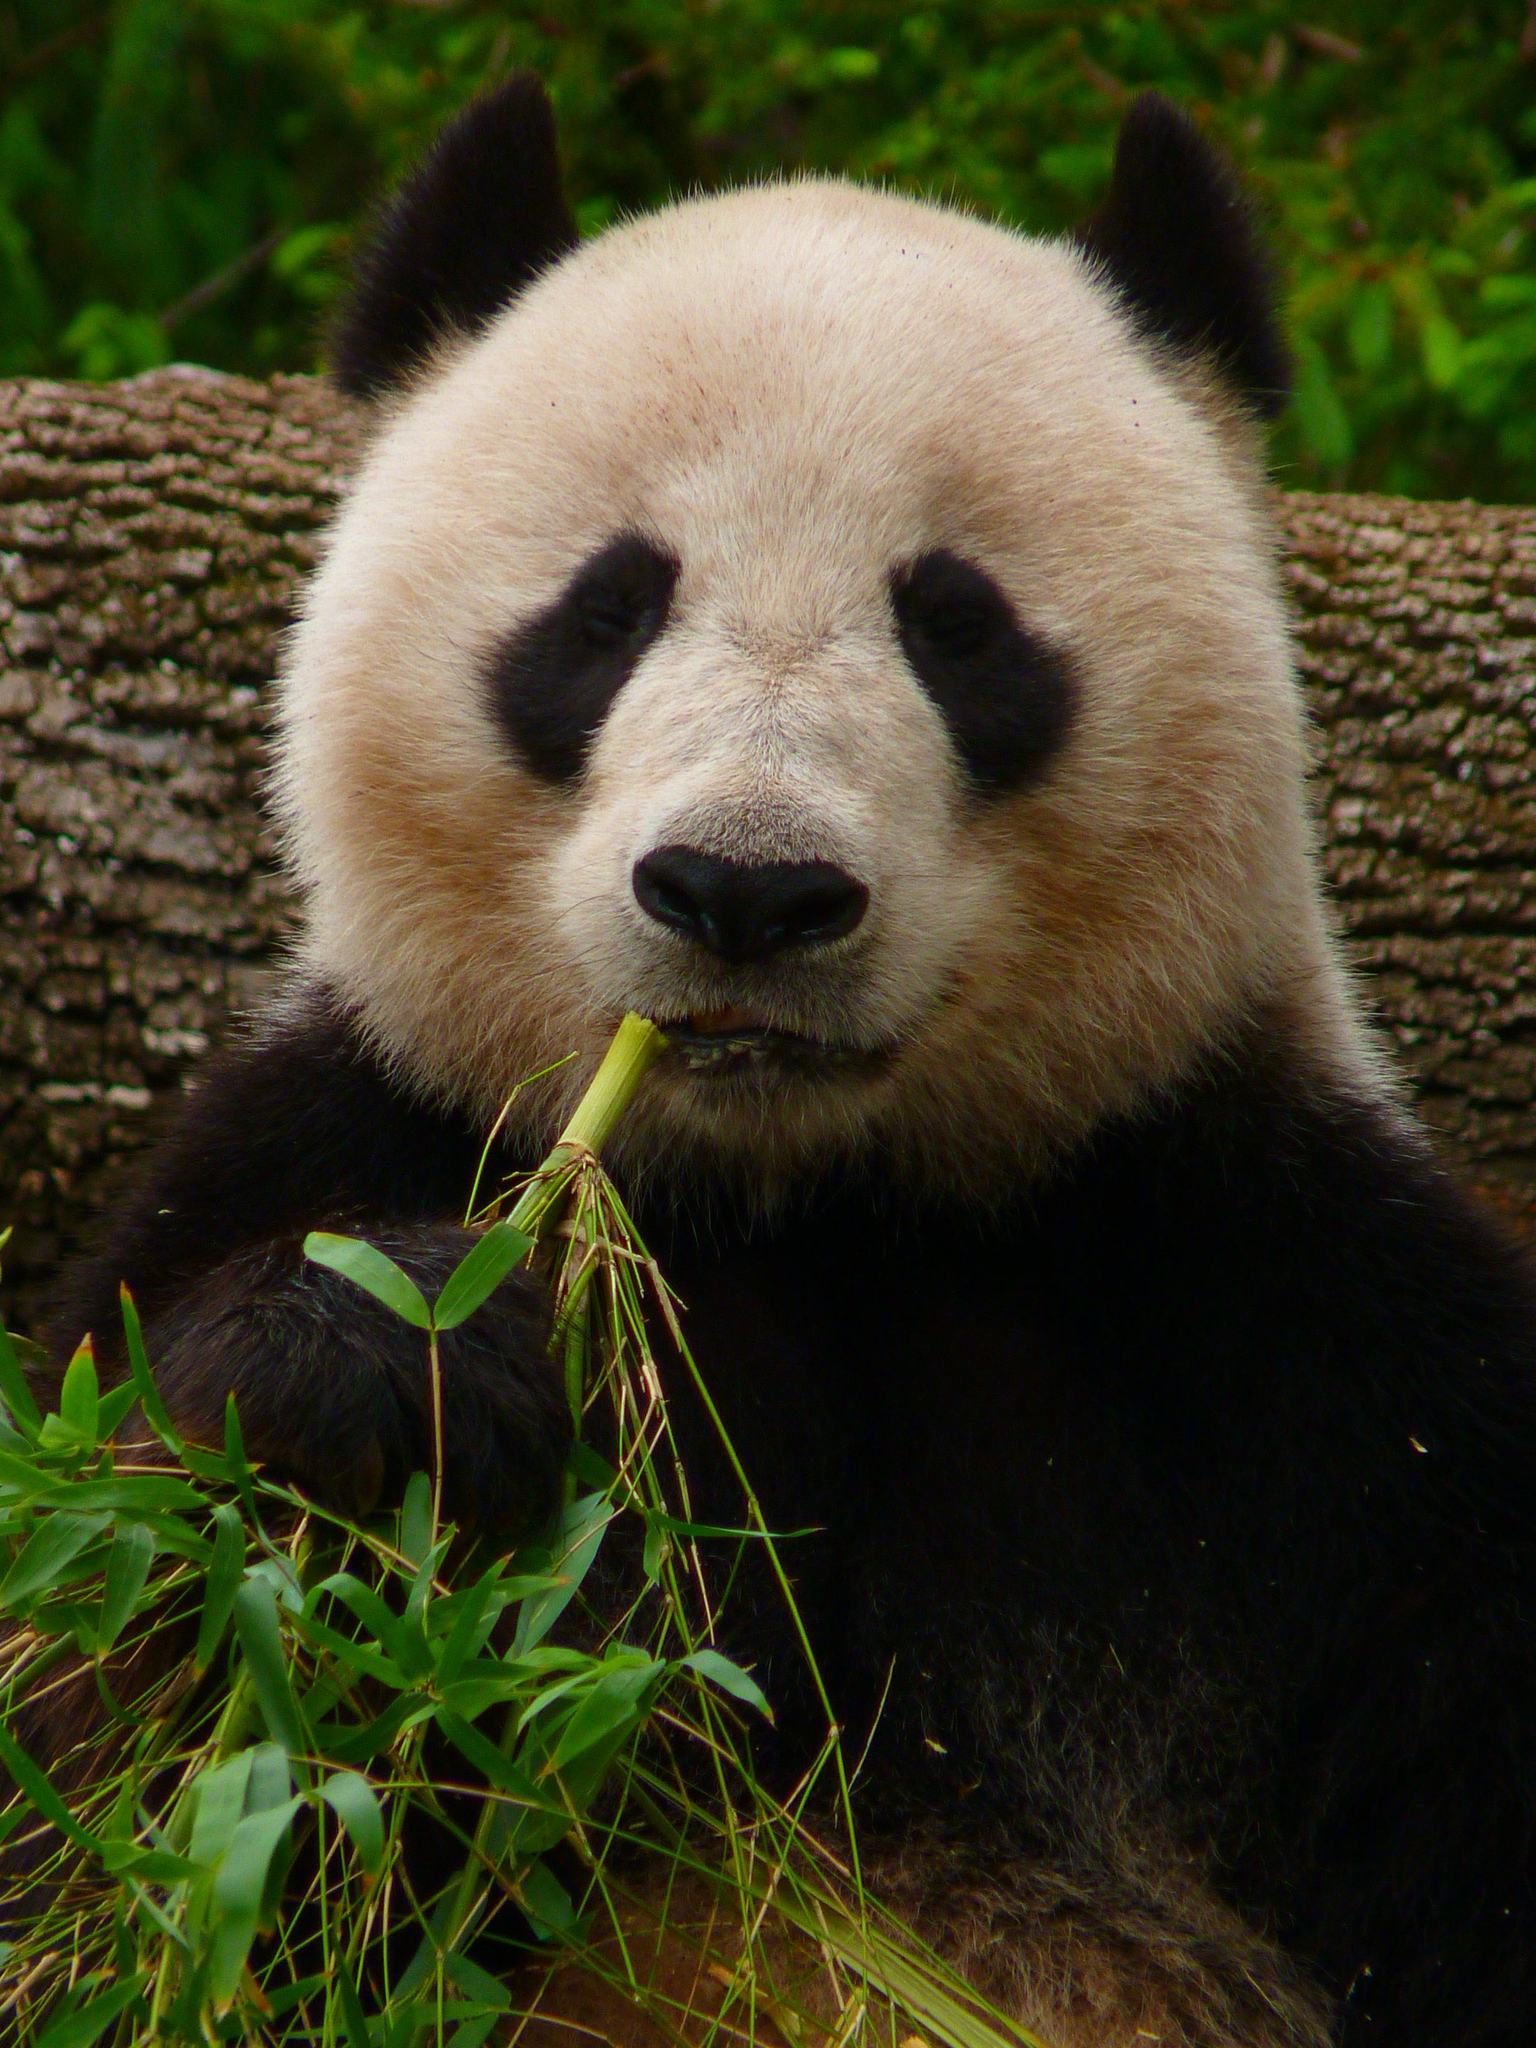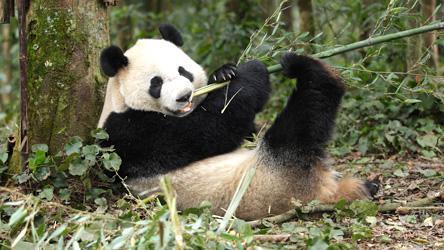The first image is the image on the left, the second image is the image on the right. For the images shown, is this caption "Each image shows a panda placing bamboo in its mouth." true? Answer yes or no. Yes. 